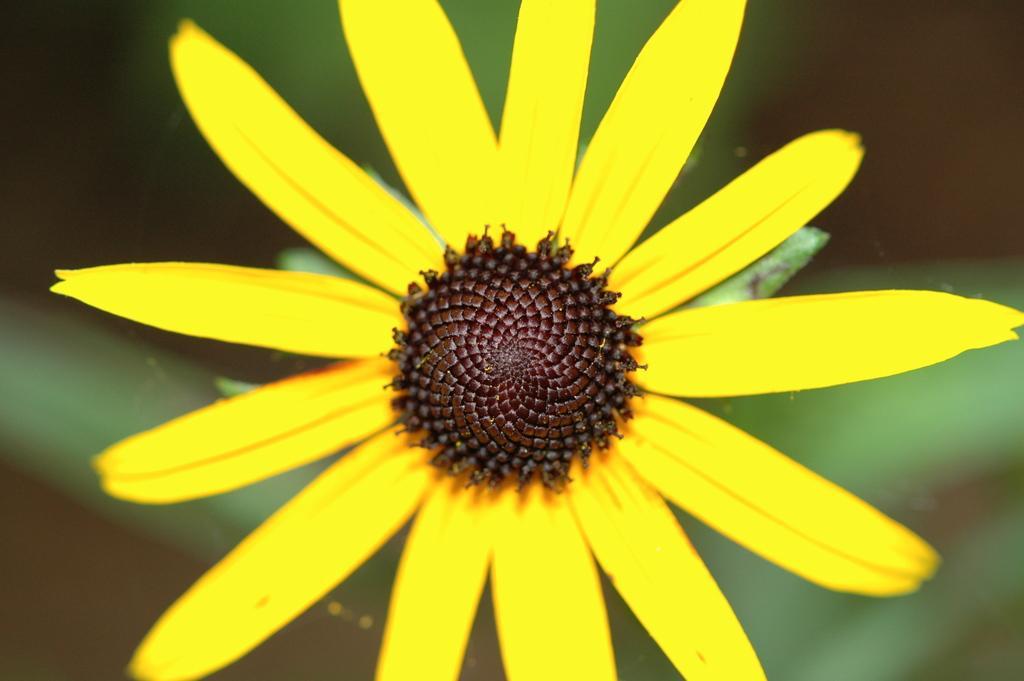How would you summarize this image in a sentence or two? In the foreground of this image, there is a yellow flower and the blurred background. 